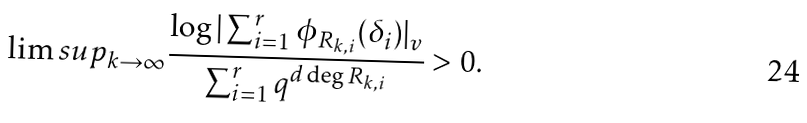<formula> <loc_0><loc_0><loc_500><loc_500>\lim s u p _ { k \to \infty } \frac { \log | \sum _ { i = 1 } ^ { r } \phi _ { R _ { k , i } } ( \delta _ { i } ) | _ { v } } { \sum _ { i = 1 } ^ { r } q ^ { d \deg R _ { k , i } } } > 0 .</formula> 